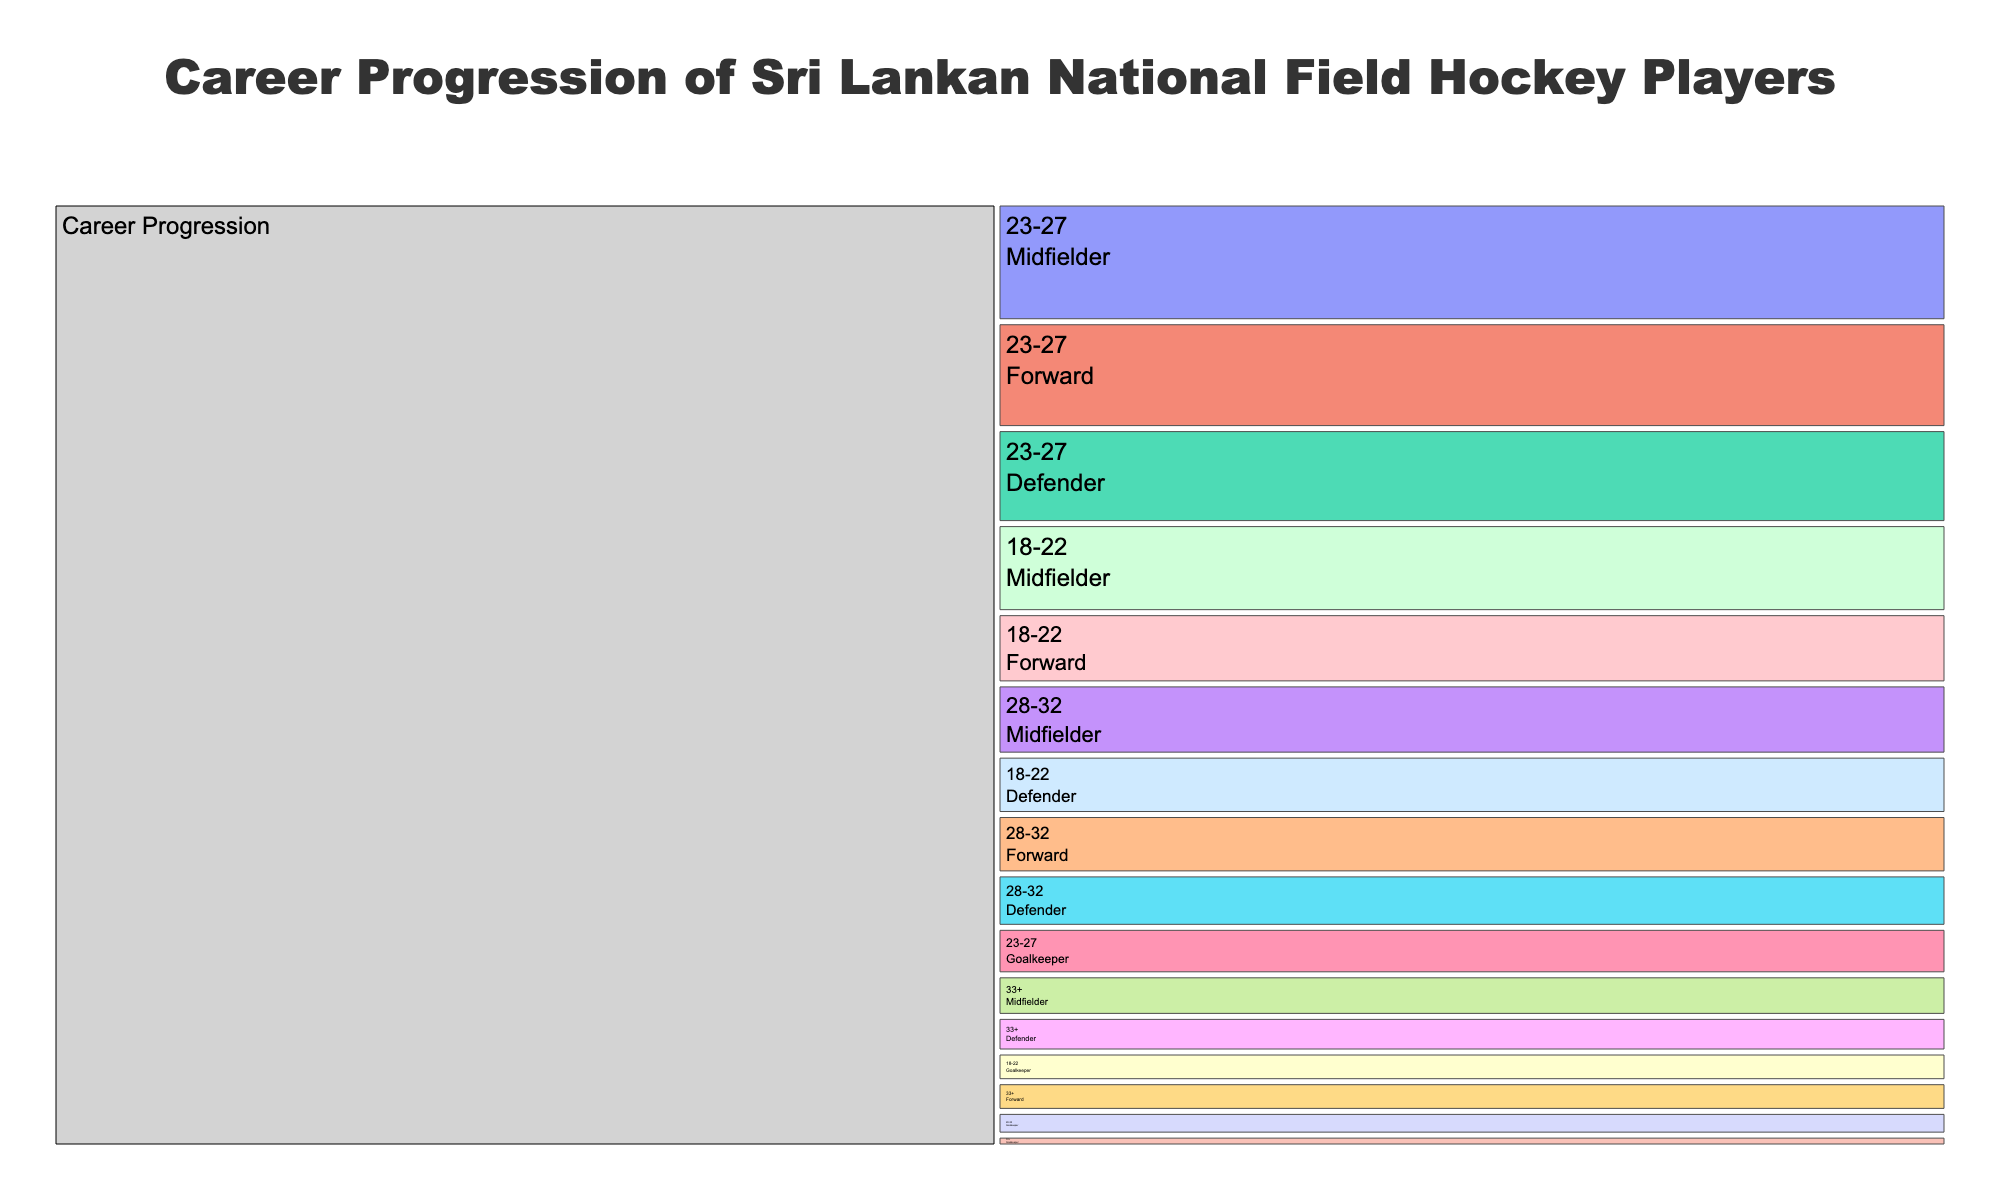what is the title of the icicle chart? The title of the chart is located at the top and is usually in a larger font size.
Answer: Career Progression of Sri Lankan National Field Hockey Players How many total players are in the 23-27 age group? The 23-27 age group has players distributed across four positions: Forward, Midfielder, Defender, and Goalkeeper. Add the number of players in each position: 18 (Forward) + 20 (Midfielder) + 16 (Defender) + 8 (Goalkeeper).
Answer: 62 Which age group has the most midfielders? Compare the number of midfielders in each age group: 18-22 has 15, 23-27 has 20, 28-32 has 12, and 33+ has 7. The 23-27 age group has the most midfielders.
Answer: 23-27 How many goalkeepers are there in total across all age groups? Sum the number of goalkeepers from each age group: 18-22 has 5, 23-27 has 8, 28-32 has 4, and 33+ has 2. The total is 5 + 8 + 4 + 2.
Answer: 19 Which position has the greatest number of players in the 18-22 age group? Compare the number of players in each position within the 18-22 age group: Forward (12), Midfielder (15), Defender (10), Goalkeeper (5). The Midfielder position has the most players.
Answer: Midfielder Are there more players in the 33+ age group or the 28-32 age group? Compare the totals for both age groups. For 33+: Forward (5) + Midfielder (7) + Defender (6) + Goalkeeper (2) = 20. For 28-32: Forward (10) + Midfielder (12) + Defender (9) + Goalkeeper (4) = 35.
Answer: 28-32 What is the total number of defenders across all age groups? Add the number of defenders from each age group: 18-22 has 10, 23-27 has 16, 28-32 has 9, and 33+ has 6. The total is 10 + 16 + 9 + 6.
Answer: 41 Is the total number of players higher in the 23-27 age group or the 18-22 age group? Determine the totals for both age groups. For 23-27: 18 (Forward) + 20 (Midfielder) + 16 (Defender) + 8 (Goalkeeper) = 62. For 18-22: 12 (Forward) + 15 (Midfielder) + 10 (Defender) + 5 (Goalkeeper) = 42.
Answer: 23-27 Which position has the fewest players in the 28-32 age group? Compare the number of players in each position within the 28-32 age group: Forward (10), Midfielder (12), Defender (9), Goalkeeper (4). The Goalkeeper position has the fewest players.
Answer: Goalkeeper 